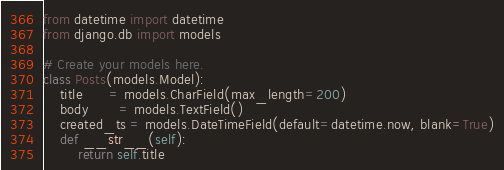<code> <loc_0><loc_0><loc_500><loc_500><_Python_>from datetime import datetime
from django.db import models

# Create your models here.
class Posts(models.Model):
    title      = models.CharField(max_length=200)
    body       = models.TextField()
    created_ts = models.DateTimeField(default=datetime.now, blank=True)
    def __str__(self):
        return self.title</code> 